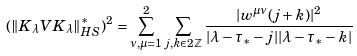<formula> <loc_0><loc_0><loc_500><loc_500>( \| K _ { \lambda } V K _ { \lambda } \| ^ { * } _ { H S } ) ^ { 2 } = \sum _ { \nu , \mu = 1 } ^ { 2 } \sum _ { j , k \in 2 \mathbb { Z } } \frac { | w ^ { \mu \nu } ( j + k ) | ^ { 2 } } { | \lambda - \tau _ { * } - j | | \lambda - \tau _ { * } - k | }</formula> 